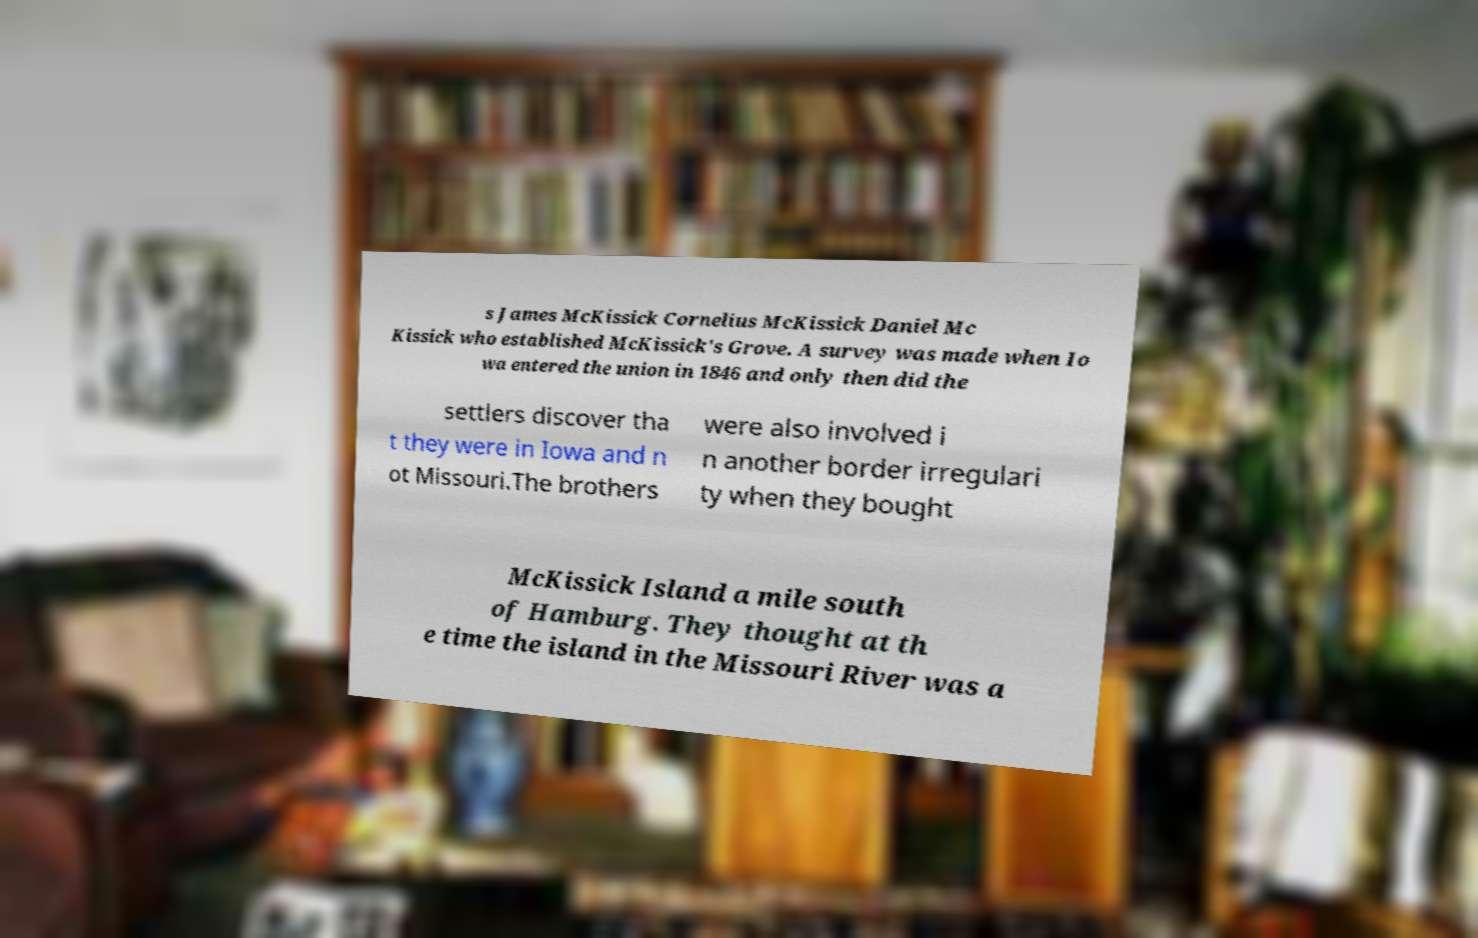There's text embedded in this image that I need extracted. Can you transcribe it verbatim? s James McKissick Cornelius McKissick Daniel Mc Kissick who established McKissick's Grove. A survey was made when Io wa entered the union in 1846 and only then did the settlers discover tha t they were in Iowa and n ot Missouri.The brothers were also involved i n another border irregulari ty when they bought McKissick Island a mile south of Hamburg. They thought at th e time the island in the Missouri River was a 